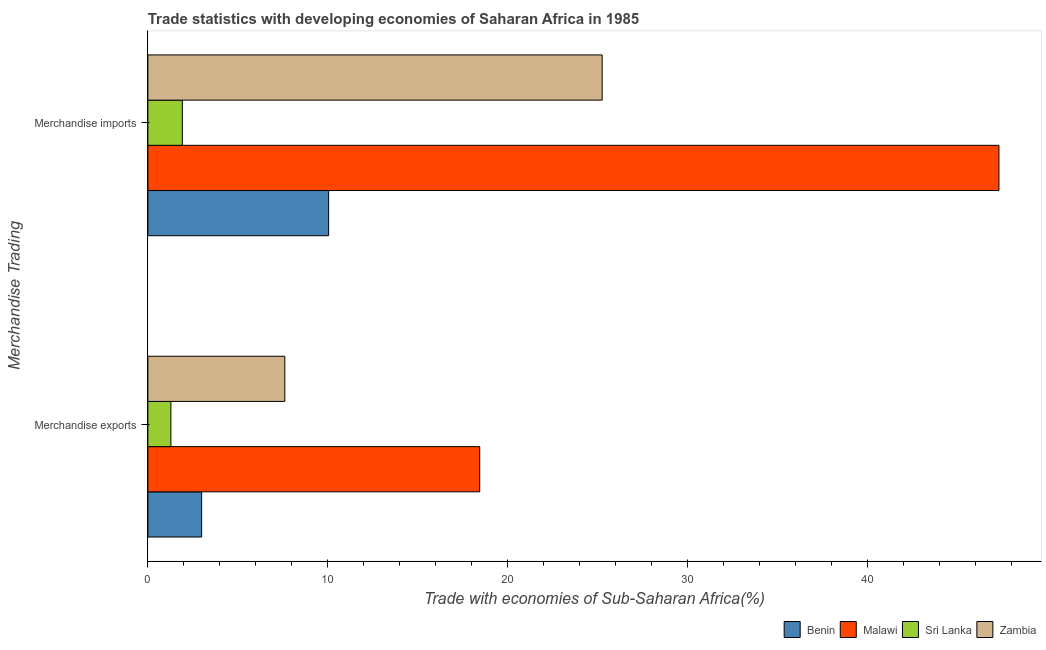How many different coloured bars are there?
Your answer should be compact. 4. Are the number of bars per tick equal to the number of legend labels?
Provide a short and direct response. Yes. Are the number of bars on each tick of the Y-axis equal?
Offer a very short reply. Yes. How many bars are there on the 1st tick from the bottom?
Ensure brevity in your answer.  4. What is the merchandise imports in Sri Lanka?
Offer a very short reply. 1.92. Across all countries, what is the maximum merchandise exports?
Offer a very short reply. 18.45. Across all countries, what is the minimum merchandise exports?
Your answer should be compact. 1.28. In which country was the merchandise imports maximum?
Provide a succinct answer. Malawi. In which country was the merchandise exports minimum?
Your answer should be compact. Sri Lanka. What is the total merchandise exports in the graph?
Give a very brief answer. 30.34. What is the difference between the merchandise exports in Malawi and that in Sri Lanka?
Provide a succinct answer. 17.17. What is the difference between the merchandise exports in Malawi and the merchandise imports in Zambia?
Ensure brevity in your answer.  -6.81. What is the average merchandise exports per country?
Your answer should be very brief. 7.58. What is the difference between the merchandise imports and merchandise exports in Zambia?
Make the answer very short. 17.65. What is the ratio of the merchandise imports in Sri Lanka to that in Zambia?
Offer a very short reply. 0.08. Is the merchandise imports in Benin less than that in Zambia?
Offer a very short reply. Yes. In how many countries, is the merchandise exports greater than the average merchandise exports taken over all countries?
Keep it short and to the point. 2. What does the 2nd bar from the top in Merchandise imports represents?
Provide a succinct answer. Sri Lanka. What does the 4th bar from the bottom in Merchandise exports represents?
Ensure brevity in your answer.  Zambia. How many countries are there in the graph?
Your answer should be very brief. 4. Are the values on the major ticks of X-axis written in scientific E-notation?
Keep it short and to the point. No. How many legend labels are there?
Offer a very short reply. 4. How are the legend labels stacked?
Keep it short and to the point. Horizontal. What is the title of the graph?
Offer a terse response. Trade statistics with developing economies of Saharan Africa in 1985. What is the label or title of the X-axis?
Offer a terse response. Trade with economies of Sub-Saharan Africa(%). What is the label or title of the Y-axis?
Keep it short and to the point. Merchandise Trading. What is the Trade with economies of Sub-Saharan Africa(%) of Benin in Merchandise exports?
Your response must be concise. 2.99. What is the Trade with economies of Sub-Saharan Africa(%) of Malawi in Merchandise exports?
Your response must be concise. 18.45. What is the Trade with economies of Sub-Saharan Africa(%) of Sri Lanka in Merchandise exports?
Provide a short and direct response. 1.28. What is the Trade with economies of Sub-Saharan Africa(%) in Zambia in Merchandise exports?
Your answer should be compact. 7.62. What is the Trade with economies of Sub-Saharan Africa(%) of Benin in Merchandise imports?
Make the answer very short. 10.05. What is the Trade with economies of Sub-Saharan Africa(%) in Malawi in Merchandise imports?
Provide a short and direct response. 47.33. What is the Trade with economies of Sub-Saharan Africa(%) of Sri Lanka in Merchandise imports?
Your response must be concise. 1.92. What is the Trade with economies of Sub-Saharan Africa(%) in Zambia in Merchandise imports?
Keep it short and to the point. 25.26. Across all Merchandise Trading, what is the maximum Trade with economies of Sub-Saharan Africa(%) of Benin?
Give a very brief answer. 10.05. Across all Merchandise Trading, what is the maximum Trade with economies of Sub-Saharan Africa(%) in Malawi?
Give a very brief answer. 47.33. Across all Merchandise Trading, what is the maximum Trade with economies of Sub-Saharan Africa(%) in Sri Lanka?
Provide a short and direct response. 1.92. Across all Merchandise Trading, what is the maximum Trade with economies of Sub-Saharan Africa(%) in Zambia?
Offer a very short reply. 25.26. Across all Merchandise Trading, what is the minimum Trade with economies of Sub-Saharan Africa(%) of Benin?
Provide a succinct answer. 2.99. Across all Merchandise Trading, what is the minimum Trade with economies of Sub-Saharan Africa(%) of Malawi?
Offer a terse response. 18.45. Across all Merchandise Trading, what is the minimum Trade with economies of Sub-Saharan Africa(%) of Sri Lanka?
Your answer should be compact. 1.28. Across all Merchandise Trading, what is the minimum Trade with economies of Sub-Saharan Africa(%) of Zambia?
Keep it short and to the point. 7.62. What is the total Trade with economies of Sub-Saharan Africa(%) of Benin in the graph?
Your answer should be very brief. 13.04. What is the total Trade with economies of Sub-Saharan Africa(%) in Malawi in the graph?
Make the answer very short. 65.78. What is the total Trade with economies of Sub-Saharan Africa(%) of Sri Lanka in the graph?
Offer a very short reply. 3.2. What is the total Trade with economies of Sub-Saharan Africa(%) in Zambia in the graph?
Make the answer very short. 32.88. What is the difference between the Trade with economies of Sub-Saharan Africa(%) of Benin in Merchandise exports and that in Merchandise imports?
Make the answer very short. -7.06. What is the difference between the Trade with economies of Sub-Saharan Africa(%) in Malawi in Merchandise exports and that in Merchandise imports?
Offer a terse response. -28.87. What is the difference between the Trade with economies of Sub-Saharan Africa(%) in Sri Lanka in Merchandise exports and that in Merchandise imports?
Give a very brief answer. -0.64. What is the difference between the Trade with economies of Sub-Saharan Africa(%) in Zambia in Merchandise exports and that in Merchandise imports?
Offer a terse response. -17.65. What is the difference between the Trade with economies of Sub-Saharan Africa(%) of Benin in Merchandise exports and the Trade with economies of Sub-Saharan Africa(%) of Malawi in Merchandise imports?
Offer a very short reply. -44.34. What is the difference between the Trade with economies of Sub-Saharan Africa(%) of Benin in Merchandise exports and the Trade with economies of Sub-Saharan Africa(%) of Sri Lanka in Merchandise imports?
Provide a succinct answer. 1.07. What is the difference between the Trade with economies of Sub-Saharan Africa(%) of Benin in Merchandise exports and the Trade with economies of Sub-Saharan Africa(%) of Zambia in Merchandise imports?
Your answer should be very brief. -22.27. What is the difference between the Trade with economies of Sub-Saharan Africa(%) in Malawi in Merchandise exports and the Trade with economies of Sub-Saharan Africa(%) in Sri Lanka in Merchandise imports?
Your response must be concise. 16.54. What is the difference between the Trade with economies of Sub-Saharan Africa(%) in Malawi in Merchandise exports and the Trade with economies of Sub-Saharan Africa(%) in Zambia in Merchandise imports?
Give a very brief answer. -6.81. What is the difference between the Trade with economies of Sub-Saharan Africa(%) in Sri Lanka in Merchandise exports and the Trade with economies of Sub-Saharan Africa(%) in Zambia in Merchandise imports?
Your response must be concise. -23.98. What is the average Trade with economies of Sub-Saharan Africa(%) in Benin per Merchandise Trading?
Provide a succinct answer. 6.52. What is the average Trade with economies of Sub-Saharan Africa(%) of Malawi per Merchandise Trading?
Offer a terse response. 32.89. What is the average Trade with economies of Sub-Saharan Africa(%) of Sri Lanka per Merchandise Trading?
Ensure brevity in your answer.  1.6. What is the average Trade with economies of Sub-Saharan Africa(%) of Zambia per Merchandise Trading?
Your response must be concise. 16.44. What is the difference between the Trade with economies of Sub-Saharan Africa(%) of Benin and Trade with economies of Sub-Saharan Africa(%) of Malawi in Merchandise exports?
Your answer should be compact. -15.46. What is the difference between the Trade with economies of Sub-Saharan Africa(%) of Benin and Trade with economies of Sub-Saharan Africa(%) of Sri Lanka in Merchandise exports?
Make the answer very short. 1.71. What is the difference between the Trade with economies of Sub-Saharan Africa(%) in Benin and Trade with economies of Sub-Saharan Africa(%) in Zambia in Merchandise exports?
Make the answer very short. -4.63. What is the difference between the Trade with economies of Sub-Saharan Africa(%) of Malawi and Trade with economies of Sub-Saharan Africa(%) of Sri Lanka in Merchandise exports?
Give a very brief answer. 17.17. What is the difference between the Trade with economies of Sub-Saharan Africa(%) in Malawi and Trade with economies of Sub-Saharan Africa(%) in Zambia in Merchandise exports?
Keep it short and to the point. 10.84. What is the difference between the Trade with economies of Sub-Saharan Africa(%) in Sri Lanka and Trade with economies of Sub-Saharan Africa(%) in Zambia in Merchandise exports?
Give a very brief answer. -6.33. What is the difference between the Trade with economies of Sub-Saharan Africa(%) of Benin and Trade with economies of Sub-Saharan Africa(%) of Malawi in Merchandise imports?
Your answer should be very brief. -37.27. What is the difference between the Trade with economies of Sub-Saharan Africa(%) in Benin and Trade with economies of Sub-Saharan Africa(%) in Sri Lanka in Merchandise imports?
Provide a short and direct response. 8.14. What is the difference between the Trade with economies of Sub-Saharan Africa(%) of Benin and Trade with economies of Sub-Saharan Africa(%) of Zambia in Merchandise imports?
Your response must be concise. -15.21. What is the difference between the Trade with economies of Sub-Saharan Africa(%) of Malawi and Trade with economies of Sub-Saharan Africa(%) of Sri Lanka in Merchandise imports?
Offer a very short reply. 45.41. What is the difference between the Trade with economies of Sub-Saharan Africa(%) in Malawi and Trade with economies of Sub-Saharan Africa(%) in Zambia in Merchandise imports?
Your response must be concise. 22.06. What is the difference between the Trade with economies of Sub-Saharan Africa(%) in Sri Lanka and Trade with economies of Sub-Saharan Africa(%) in Zambia in Merchandise imports?
Offer a very short reply. -23.35. What is the ratio of the Trade with economies of Sub-Saharan Africa(%) in Benin in Merchandise exports to that in Merchandise imports?
Give a very brief answer. 0.3. What is the ratio of the Trade with economies of Sub-Saharan Africa(%) of Malawi in Merchandise exports to that in Merchandise imports?
Your response must be concise. 0.39. What is the ratio of the Trade with economies of Sub-Saharan Africa(%) in Sri Lanka in Merchandise exports to that in Merchandise imports?
Provide a short and direct response. 0.67. What is the ratio of the Trade with economies of Sub-Saharan Africa(%) of Zambia in Merchandise exports to that in Merchandise imports?
Your response must be concise. 0.3. What is the difference between the highest and the second highest Trade with economies of Sub-Saharan Africa(%) of Benin?
Offer a terse response. 7.06. What is the difference between the highest and the second highest Trade with economies of Sub-Saharan Africa(%) of Malawi?
Give a very brief answer. 28.87. What is the difference between the highest and the second highest Trade with economies of Sub-Saharan Africa(%) of Sri Lanka?
Your answer should be very brief. 0.64. What is the difference between the highest and the second highest Trade with economies of Sub-Saharan Africa(%) of Zambia?
Your answer should be very brief. 17.65. What is the difference between the highest and the lowest Trade with economies of Sub-Saharan Africa(%) of Benin?
Offer a very short reply. 7.06. What is the difference between the highest and the lowest Trade with economies of Sub-Saharan Africa(%) in Malawi?
Offer a terse response. 28.87. What is the difference between the highest and the lowest Trade with economies of Sub-Saharan Africa(%) in Sri Lanka?
Provide a short and direct response. 0.64. What is the difference between the highest and the lowest Trade with economies of Sub-Saharan Africa(%) of Zambia?
Your answer should be compact. 17.65. 